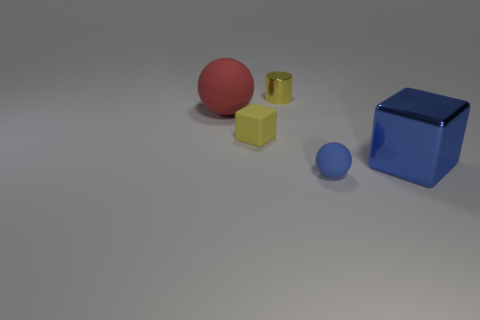There is a blue shiny thing; is it the same shape as the matte object in front of the yellow matte object?
Offer a very short reply. No. The sphere that is the same size as the yellow cylinder is what color?
Offer a terse response. Blue. Are there fewer small blue objects that are left of the red object than tiny spheres that are left of the small blue ball?
Ensure brevity in your answer.  No. The small yellow object behind the large object behind the metallic object in front of the yellow metal cylinder is what shape?
Provide a succinct answer. Cylinder. Do the metallic thing that is in front of the red matte thing and the rubber sphere that is on the left side of the yellow shiny thing have the same color?
Provide a succinct answer. No. There is a tiny rubber thing that is the same color as the cylinder; what shape is it?
Provide a short and direct response. Cube. What number of matte objects are either small yellow objects or big gray balls?
Your answer should be very brief. 1. The rubber thing on the left side of the small yellow thing in front of the big thing to the left of the big blue shiny block is what color?
Your answer should be compact. Red. There is another matte thing that is the same shape as the small blue object; what is its color?
Keep it short and to the point. Red. Is there anything else of the same color as the small shiny cylinder?
Ensure brevity in your answer.  Yes. 